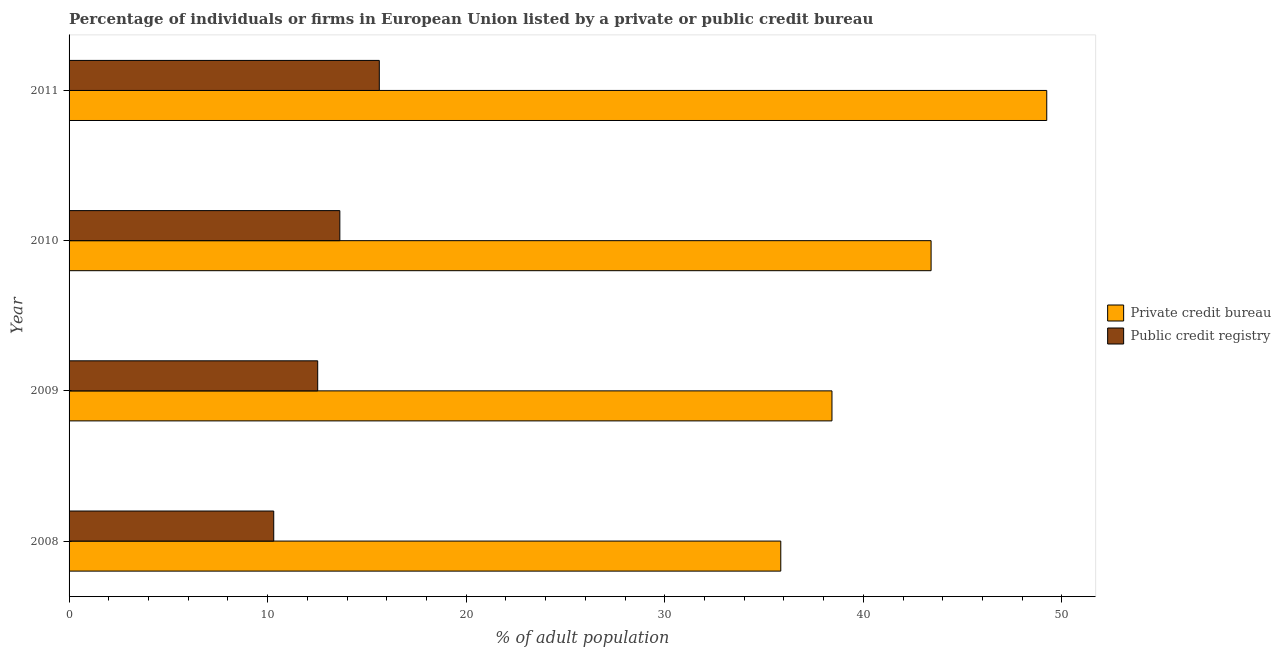How many groups of bars are there?
Keep it short and to the point. 4. Are the number of bars per tick equal to the number of legend labels?
Your answer should be compact. Yes. How many bars are there on the 4th tick from the top?
Provide a succinct answer. 2. What is the label of the 4th group of bars from the top?
Ensure brevity in your answer.  2008. In how many cases, is the number of bars for a given year not equal to the number of legend labels?
Offer a terse response. 0. What is the percentage of firms listed by public credit bureau in 2008?
Ensure brevity in your answer.  10.31. Across all years, what is the maximum percentage of firms listed by private credit bureau?
Provide a succinct answer. 49.24. Across all years, what is the minimum percentage of firms listed by private credit bureau?
Keep it short and to the point. 35.84. In which year was the percentage of firms listed by public credit bureau minimum?
Make the answer very short. 2008. What is the total percentage of firms listed by public credit bureau in the graph?
Keep it short and to the point. 52.09. What is the difference between the percentage of firms listed by private credit bureau in 2009 and that in 2010?
Keep it short and to the point. -4.99. What is the difference between the percentage of firms listed by public credit bureau in 2008 and the percentage of firms listed by private credit bureau in 2010?
Ensure brevity in your answer.  -33.11. What is the average percentage of firms listed by public credit bureau per year?
Offer a very short reply. 13.02. In the year 2009, what is the difference between the percentage of firms listed by public credit bureau and percentage of firms listed by private credit bureau?
Provide a short and direct response. -25.9. In how many years, is the percentage of firms listed by private credit bureau greater than 48 %?
Give a very brief answer. 1. What is the ratio of the percentage of firms listed by public credit bureau in 2009 to that in 2010?
Your answer should be very brief. 0.92. Is the percentage of firms listed by private credit bureau in 2008 less than that in 2009?
Provide a short and direct response. Yes. Is the difference between the percentage of firms listed by private credit bureau in 2008 and 2009 greater than the difference between the percentage of firms listed by public credit bureau in 2008 and 2009?
Your answer should be compact. No. What is the difference between the highest and the second highest percentage of firms listed by private credit bureau?
Give a very brief answer. 5.82. What is the difference between the highest and the lowest percentage of firms listed by public credit bureau?
Offer a very short reply. 5.32. In how many years, is the percentage of firms listed by private credit bureau greater than the average percentage of firms listed by private credit bureau taken over all years?
Offer a very short reply. 2. What does the 1st bar from the top in 2010 represents?
Provide a succinct answer. Public credit registry. What does the 2nd bar from the bottom in 2011 represents?
Give a very brief answer. Public credit registry. Are all the bars in the graph horizontal?
Give a very brief answer. Yes. How many years are there in the graph?
Provide a succinct answer. 4. Are the values on the major ticks of X-axis written in scientific E-notation?
Offer a terse response. No. Does the graph contain any zero values?
Your response must be concise. No. Does the graph contain grids?
Make the answer very short. No. How many legend labels are there?
Ensure brevity in your answer.  2. How are the legend labels stacked?
Your answer should be compact. Vertical. What is the title of the graph?
Make the answer very short. Percentage of individuals or firms in European Union listed by a private or public credit bureau. Does "Arms exports" appear as one of the legend labels in the graph?
Provide a short and direct response. No. What is the label or title of the X-axis?
Your response must be concise. % of adult population. What is the % of adult population in Private credit bureau in 2008?
Offer a terse response. 35.84. What is the % of adult population of Public credit registry in 2008?
Your answer should be compact. 10.31. What is the % of adult population in Private credit bureau in 2009?
Your response must be concise. 38.42. What is the % of adult population in Public credit registry in 2009?
Make the answer very short. 12.52. What is the % of adult population in Private credit bureau in 2010?
Provide a short and direct response. 43.41. What is the % of adult population in Public credit registry in 2010?
Give a very brief answer. 13.64. What is the % of adult population in Private credit bureau in 2011?
Provide a succinct answer. 49.24. What is the % of adult population in Public credit registry in 2011?
Give a very brief answer. 15.62. Across all years, what is the maximum % of adult population of Private credit bureau?
Your answer should be very brief. 49.24. Across all years, what is the maximum % of adult population of Public credit registry?
Your answer should be very brief. 15.62. Across all years, what is the minimum % of adult population in Private credit bureau?
Offer a very short reply. 35.84. Across all years, what is the minimum % of adult population of Public credit registry?
Offer a terse response. 10.31. What is the total % of adult population of Private credit bureau in the graph?
Provide a short and direct response. 166.92. What is the total % of adult population in Public credit registry in the graph?
Keep it short and to the point. 52.09. What is the difference between the % of adult population of Private credit bureau in 2008 and that in 2009?
Provide a succinct answer. -2.58. What is the difference between the % of adult population in Public credit registry in 2008 and that in 2009?
Your response must be concise. -2.21. What is the difference between the % of adult population of Private credit bureau in 2008 and that in 2010?
Your answer should be very brief. -7.57. What is the difference between the % of adult population of Public credit registry in 2008 and that in 2010?
Your answer should be very brief. -3.33. What is the difference between the % of adult population of Private credit bureau in 2008 and that in 2011?
Offer a terse response. -13.39. What is the difference between the % of adult population in Public credit registry in 2008 and that in 2011?
Your response must be concise. -5.32. What is the difference between the % of adult population of Private credit bureau in 2009 and that in 2010?
Keep it short and to the point. -4.99. What is the difference between the % of adult population in Public credit registry in 2009 and that in 2010?
Ensure brevity in your answer.  -1.11. What is the difference between the % of adult population of Private credit bureau in 2009 and that in 2011?
Offer a very short reply. -10.82. What is the difference between the % of adult population of Public credit registry in 2009 and that in 2011?
Offer a very short reply. -3.1. What is the difference between the % of adult population in Private credit bureau in 2010 and that in 2011?
Offer a very short reply. -5.82. What is the difference between the % of adult population of Public credit registry in 2010 and that in 2011?
Offer a very short reply. -1.99. What is the difference between the % of adult population of Private credit bureau in 2008 and the % of adult population of Public credit registry in 2009?
Give a very brief answer. 23.32. What is the difference between the % of adult population of Private credit bureau in 2008 and the % of adult population of Public credit registry in 2010?
Your answer should be very brief. 22.21. What is the difference between the % of adult population of Private credit bureau in 2008 and the % of adult population of Public credit registry in 2011?
Ensure brevity in your answer.  20.22. What is the difference between the % of adult population of Private credit bureau in 2009 and the % of adult population of Public credit registry in 2010?
Ensure brevity in your answer.  24.79. What is the difference between the % of adult population of Private credit bureau in 2009 and the % of adult population of Public credit registry in 2011?
Provide a succinct answer. 22.8. What is the difference between the % of adult population in Private credit bureau in 2010 and the % of adult population in Public credit registry in 2011?
Provide a succinct answer. 27.79. What is the average % of adult population of Private credit bureau per year?
Your answer should be very brief. 41.73. What is the average % of adult population in Public credit registry per year?
Keep it short and to the point. 13.02. In the year 2008, what is the difference between the % of adult population of Private credit bureau and % of adult population of Public credit registry?
Your answer should be very brief. 25.54. In the year 2009, what is the difference between the % of adult population of Private credit bureau and % of adult population of Public credit registry?
Your answer should be compact. 25.9. In the year 2010, what is the difference between the % of adult population of Private credit bureau and % of adult population of Public credit registry?
Give a very brief answer. 29.78. In the year 2011, what is the difference between the % of adult population in Private credit bureau and % of adult population in Public credit registry?
Your response must be concise. 33.61. What is the ratio of the % of adult population in Private credit bureau in 2008 to that in 2009?
Your response must be concise. 0.93. What is the ratio of the % of adult population of Public credit registry in 2008 to that in 2009?
Provide a succinct answer. 0.82. What is the ratio of the % of adult population in Private credit bureau in 2008 to that in 2010?
Keep it short and to the point. 0.83. What is the ratio of the % of adult population in Public credit registry in 2008 to that in 2010?
Ensure brevity in your answer.  0.76. What is the ratio of the % of adult population of Private credit bureau in 2008 to that in 2011?
Give a very brief answer. 0.73. What is the ratio of the % of adult population in Public credit registry in 2008 to that in 2011?
Make the answer very short. 0.66. What is the ratio of the % of adult population of Private credit bureau in 2009 to that in 2010?
Provide a short and direct response. 0.89. What is the ratio of the % of adult population in Public credit registry in 2009 to that in 2010?
Provide a succinct answer. 0.92. What is the ratio of the % of adult population of Private credit bureau in 2009 to that in 2011?
Make the answer very short. 0.78. What is the ratio of the % of adult population of Public credit registry in 2009 to that in 2011?
Offer a very short reply. 0.8. What is the ratio of the % of adult population of Private credit bureau in 2010 to that in 2011?
Provide a short and direct response. 0.88. What is the ratio of the % of adult population of Public credit registry in 2010 to that in 2011?
Offer a very short reply. 0.87. What is the difference between the highest and the second highest % of adult population of Private credit bureau?
Ensure brevity in your answer.  5.82. What is the difference between the highest and the second highest % of adult population of Public credit registry?
Make the answer very short. 1.99. What is the difference between the highest and the lowest % of adult population of Private credit bureau?
Provide a succinct answer. 13.39. What is the difference between the highest and the lowest % of adult population of Public credit registry?
Keep it short and to the point. 5.32. 